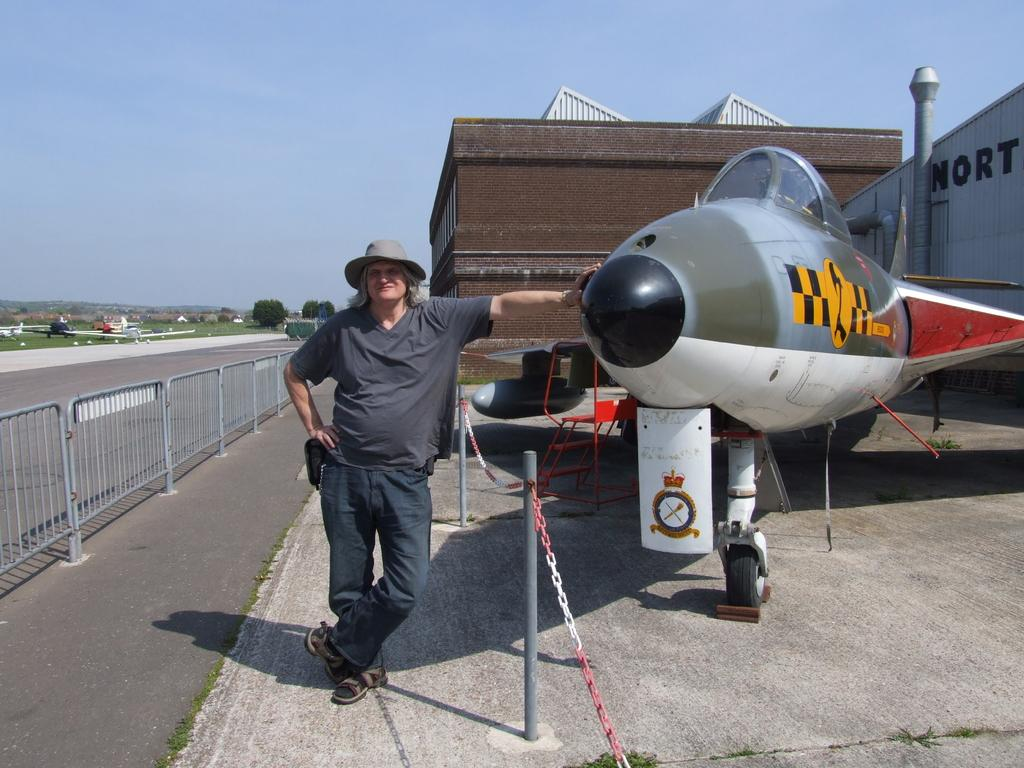Provide a one-sentence caption for the provided image. An airplane is parked in front of a building whose name starts with NORT. 